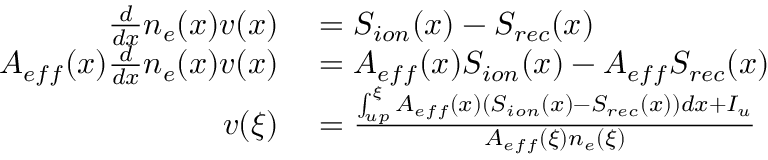Convert formula to latex. <formula><loc_0><loc_0><loc_500><loc_500>\begin{array} { r l } { \frac { d } { d x } n _ { e } ( x ) v ( x ) } & = S _ { i o n } ( x ) - S _ { r e c } ( x ) } \\ { A _ { e f f } ( x ) \frac { d } { d x } n _ { e } ( x ) v ( x ) } & = A _ { e f f } ( x ) S _ { i o n } ( x ) - A _ { e f f } S _ { r e c } ( x ) } \\ { v ( \xi ) } & = \frac { \int _ { u p } ^ { \xi } A _ { e f f } ( x ) ( S _ { i o n } ( x ) - S _ { r e c } ( x ) ) d x + I _ { u } } { A _ { e f f } ( \xi ) n _ { e } ( \xi ) } } \end{array}</formula> 